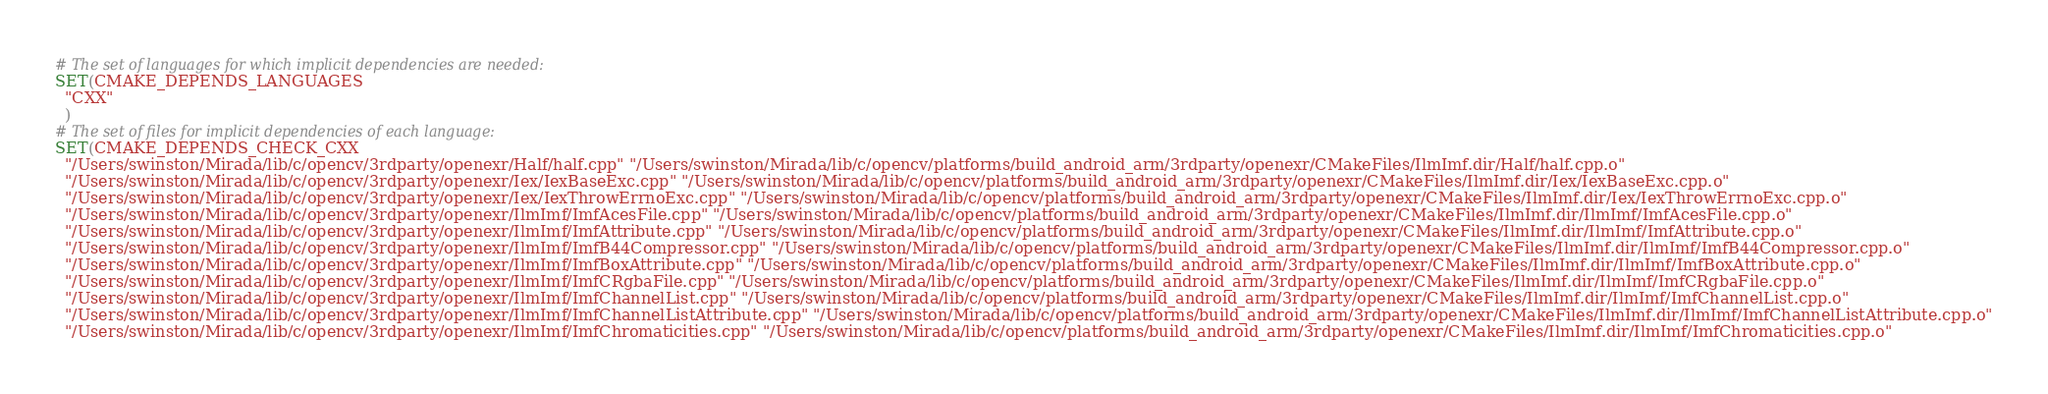Convert code to text. <code><loc_0><loc_0><loc_500><loc_500><_CMake_># The set of languages for which implicit dependencies are needed:
SET(CMAKE_DEPENDS_LANGUAGES
  "CXX"
  )
# The set of files for implicit dependencies of each language:
SET(CMAKE_DEPENDS_CHECK_CXX
  "/Users/swinston/Mirada/lib/c/opencv/3rdparty/openexr/Half/half.cpp" "/Users/swinston/Mirada/lib/c/opencv/platforms/build_android_arm/3rdparty/openexr/CMakeFiles/IlmImf.dir/Half/half.cpp.o"
  "/Users/swinston/Mirada/lib/c/opencv/3rdparty/openexr/Iex/IexBaseExc.cpp" "/Users/swinston/Mirada/lib/c/opencv/platforms/build_android_arm/3rdparty/openexr/CMakeFiles/IlmImf.dir/Iex/IexBaseExc.cpp.o"
  "/Users/swinston/Mirada/lib/c/opencv/3rdparty/openexr/Iex/IexThrowErrnoExc.cpp" "/Users/swinston/Mirada/lib/c/opencv/platforms/build_android_arm/3rdparty/openexr/CMakeFiles/IlmImf.dir/Iex/IexThrowErrnoExc.cpp.o"
  "/Users/swinston/Mirada/lib/c/opencv/3rdparty/openexr/IlmImf/ImfAcesFile.cpp" "/Users/swinston/Mirada/lib/c/opencv/platforms/build_android_arm/3rdparty/openexr/CMakeFiles/IlmImf.dir/IlmImf/ImfAcesFile.cpp.o"
  "/Users/swinston/Mirada/lib/c/opencv/3rdparty/openexr/IlmImf/ImfAttribute.cpp" "/Users/swinston/Mirada/lib/c/opencv/platforms/build_android_arm/3rdparty/openexr/CMakeFiles/IlmImf.dir/IlmImf/ImfAttribute.cpp.o"
  "/Users/swinston/Mirada/lib/c/opencv/3rdparty/openexr/IlmImf/ImfB44Compressor.cpp" "/Users/swinston/Mirada/lib/c/opencv/platforms/build_android_arm/3rdparty/openexr/CMakeFiles/IlmImf.dir/IlmImf/ImfB44Compressor.cpp.o"
  "/Users/swinston/Mirada/lib/c/opencv/3rdparty/openexr/IlmImf/ImfBoxAttribute.cpp" "/Users/swinston/Mirada/lib/c/opencv/platforms/build_android_arm/3rdparty/openexr/CMakeFiles/IlmImf.dir/IlmImf/ImfBoxAttribute.cpp.o"
  "/Users/swinston/Mirada/lib/c/opencv/3rdparty/openexr/IlmImf/ImfCRgbaFile.cpp" "/Users/swinston/Mirada/lib/c/opencv/platforms/build_android_arm/3rdparty/openexr/CMakeFiles/IlmImf.dir/IlmImf/ImfCRgbaFile.cpp.o"
  "/Users/swinston/Mirada/lib/c/opencv/3rdparty/openexr/IlmImf/ImfChannelList.cpp" "/Users/swinston/Mirada/lib/c/opencv/platforms/build_android_arm/3rdparty/openexr/CMakeFiles/IlmImf.dir/IlmImf/ImfChannelList.cpp.o"
  "/Users/swinston/Mirada/lib/c/opencv/3rdparty/openexr/IlmImf/ImfChannelListAttribute.cpp" "/Users/swinston/Mirada/lib/c/opencv/platforms/build_android_arm/3rdparty/openexr/CMakeFiles/IlmImf.dir/IlmImf/ImfChannelListAttribute.cpp.o"
  "/Users/swinston/Mirada/lib/c/opencv/3rdparty/openexr/IlmImf/ImfChromaticities.cpp" "/Users/swinston/Mirada/lib/c/opencv/platforms/build_android_arm/3rdparty/openexr/CMakeFiles/IlmImf.dir/IlmImf/ImfChromaticities.cpp.o"</code> 